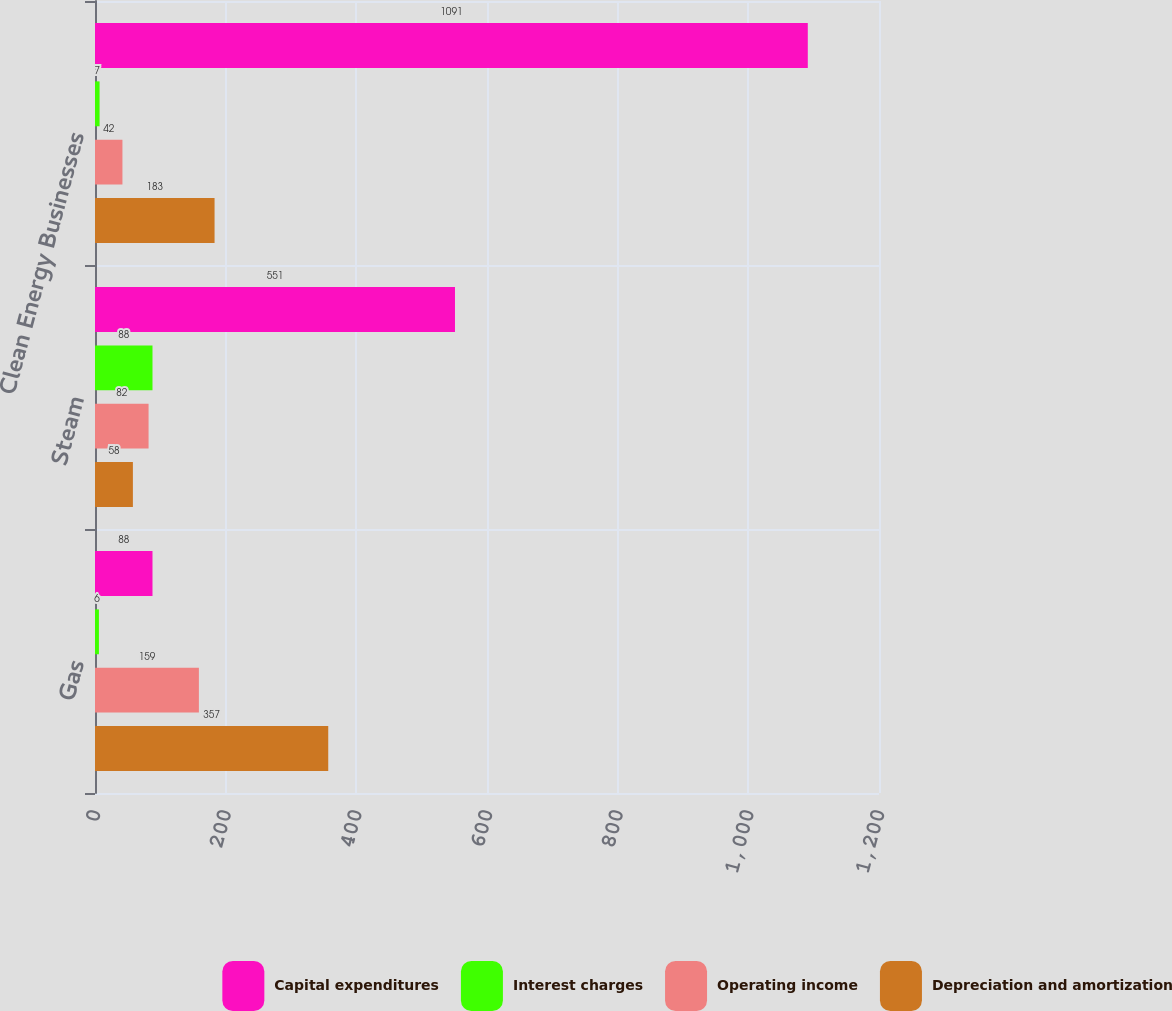<chart> <loc_0><loc_0><loc_500><loc_500><stacked_bar_chart><ecel><fcel>Gas<fcel>Steam<fcel>Clean Energy Businesses<nl><fcel>Capital expenditures<fcel>88<fcel>551<fcel>1091<nl><fcel>Interest charges<fcel>6<fcel>88<fcel>7<nl><fcel>Operating income<fcel>159<fcel>82<fcel>42<nl><fcel>Depreciation and amortization<fcel>357<fcel>58<fcel>183<nl></chart> 